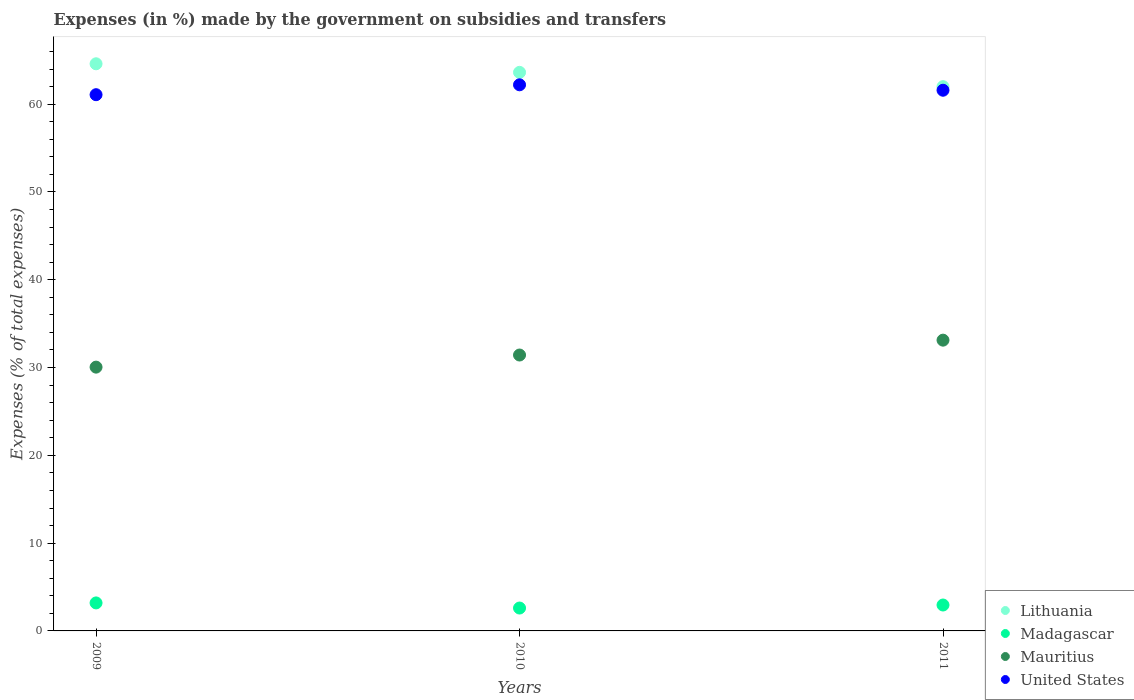How many different coloured dotlines are there?
Give a very brief answer. 4. Is the number of dotlines equal to the number of legend labels?
Give a very brief answer. Yes. What is the percentage of expenses made by the government on subsidies and transfers in United States in 2009?
Provide a short and direct response. 61.07. Across all years, what is the maximum percentage of expenses made by the government on subsidies and transfers in Mauritius?
Ensure brevity in your answer.  33.12. Across all years, what is the minimum percentage of expenses made by the government on subsidies and transfers in Madagascar?
Provide a succinct answer. 2.61. What is the total percentage of expenses made by the government on subsidies and transfers in Madagascar in the graph?
Ensure brevity in your answer.  8.75. What is the difference between the percentage of expenses made by the government on subsidies and transfers in Lithuania in 2009 and that in 2011?
Provide a short and direct response. 2.61. What is the difference between the percentage of expenses made by the government on subsidies and transfers in United States in 2011 and the percentage of expenses made by the government on subsidies and transfers in Madagascar in 2010?
Your response must be concise. 58.98. What is the average percentage of expenses made by the government on subsidies and transfers in United States per year?
Offer a very short reply. 61.62. In the year 2011, what is the difference between the percentage of expenses made by the government on subsidies and transfers in Mauritius and percentage of expenses made by the government on subsidies and transfers in United States?
Your response must be concise. -28.46. What is the ratio of the percentage of expenses made by the government on subsidies and transfers in United States in 2009 to that in 2011?
Your answer should be very brief. 0.99. What is the difference between the highest and the second highest percentage of expenses made by the government on subsidies and transfers in Mauritius?
Your answer should be compact. 1.69. What is the difference between the highest and the lowest percentage of expenses made by the government on subsidies and transfers in United States?
Your answer should be very brief. 1.13. Is it the case that in every year, the sum of the percentage of expenses made by the government on subsidies and transfers in Madagascar and percentage of expenses made by the government on subsidies and transfers in Lithuania  is greater than the sum of percentage of expenses made by the government on subsidies and transfers in United States and percentage of expenses made by the government on subsidies and transfers in Mauritius?
Provide a short and direct response. No. Is it the case that in every year, the sum of the percentage of expenses made by the government on subsidies and transfers in Lithuania and percentage of expenses made by the government on subsidies and transfers in United States  is greater than the percentage of expenses made by the government on subsidies and transfers in Mauritius?
Make the answer very short. Yes. Does the percentage of expenses made by the government on subsidies and transfers in United States monotonically increase over the years?
Your response must be concise. No. Is the percentage of expenses made by the government on subsidies and transfers in Mauritius strictly greater than the percentage of expenses made by the government on subsidies and transfers in Madagascar over the years?
Give a very brief answer. Yes. How many dotlines are there?
Ensure brevity in your answer.  4. How many legend labels are there?
Your response must be concise. 4. What is the title of the graph?
Ensure brevity in your answer.  Expenses (in %) made by the government on subsidies and transfers. Does "Tajikistan" appear as one of the legend labels in the graph?
Offer a very short reply. No. What is the label or title of the Y-axis?
Your answer should be very brief. Expenses (% of total expenses). What is the Expenses (% of total expenses) of Lithuania in 2009?
Your response must be concise. 64.59. What is the Expenses (% of total expenses) of Madagascar in 2009?
Provide a succinct answer. 3.19. What is the Expenses (% of total expenses) of Mauritius in 2009?
Give a very brief answer. 30.04. What is the Expenses (% of total expenses) in United States in 2009?
Ensure brevity in your answer.  61.07. What is the Expenses (% of total expenses) of Lithuania in 2010?
Your answer should be very brief. 63.62. What is the Expenses (% of total expenses) in Madagascar in 2010?
Ensure brevity in your answer.  2.61. What is the Expenses (% of total expenses) in Mauritius in 2010?
Provide a short and direct response. 31.42. What is the Expenses (% of total expenses) in United States in 2010?
Keep it short and to the point. 62.2. What is the Expenses (% of total expenses) of Lithuania in 2011?
Offer a terse response. 61.99. What is the Expenses (% of total expenses) in Madagascar in 2011?
Your answer should be compact. 2.95. What is the Expenses (% of total expenses) in Mauritius in 2011?
Provide a succinct answer. 33.12. What is the Expenses (% of total expenses) in United States in 2011?
Your answer should be compact. 61.58. Across all years, what is the maximum Expenses (% of total expenses) in Lithuania?
Make the answer very short. 64.59. Across all years, what is the maximum Expenses (% of total expenses) in Madagascar?
Your answer should be compact. 3.19. Across all years, what is the maximum Expenses (% of total expenses) in Mauritius?
Offer a terse response. 33.12. Across all years, what is the maximum Expenses (% of total expenses) in United States?
Keep it short and to the point. 62.2. Across all years, what is the minimum Expenses (% of total expenses) in Lithuania?
Ensure brevity in your answer.  61.99. Across all years, what is the minimum Expenses (% of total expenses) of Madagascar?
Your response must be concise. 2.61. Across all years, what is the minimum Expenses (% of total expenses) in Mauritius?
Offer a very short reply. 30.04. Across all years, what is the minimum Expenses (% of total expenses) of United States?
Your response must be concise. 61.07. What is the total Expenses (% of total expenses) of Lithuania in the graph?
Keep it short and to the point. 190.2. What is the total Expenses (% of total expenses) of Madagascar in the graph?
Keep it short and to the point. 8.75. What is the total Expenses (% of total expenses) in Mauritius in the graph?
Ensure brevity in your answer.  94.58. What is the total Expenses (% of total expenses) of United States in the graph?
Provide a short and direct response. 184.86. What is the difference between the Expenses (% of total expenses) in Lithuania in 2009 and that in 2010?
Ensure brevity in your answer.  0.98. What is the difference between the Expenses (% of total expenses) of Madagascar in 2009 and that in 2010?
Your answer should be very brief. 0.58. What is the difference between the Expenses (% of total expenses) of Mauritius in 2009 and that in 2010?
Ensure brevity in your answer.  -1.38. What is the difference between the Expenses (% of total expenses) in United States in 2009 and that in 2010?
Your answer should be very brief. -1.13. What is the difference between the Expenses (% of total expenses) of Lithuania in 2009 and that in 2011?
Your response must be concise. 2.61. What is the difference between the Expenses (% of total expenses) of Madagascar in 2009 and that in 2011?
Your answer should be very brief. 0.24. What is the difference between the Expenses (% of total expenses) of Mauritius in 2009 and that in 2011?
Your response must be concise. -3.07. What is the difference between the Expenses (% of total expenses) of United States in 2009 and that in 2011?
Provide a short and direct response. -0.51. What is the difference between the Expenses (% of total expenses) of Lithuania in 2010 and that in 2011?
Your answer should be very brief. 1.63. What is the difference between the Expenses (% of total expenses) in Madagascar in 2010 and that in 2011?
Offer a terse response. -0.34. What is the difference between the Expenses (% of total expenses) in Mauritius in 2010 and that in 2011?
Make the answer very short. -1.69. What is the difference between the Expenses (% of total expenses) in United States in 2010 and that in 2011?
Your answer should be compact. 0.62. What is the difference between the Expenses (% of total expenses) of Lithuania in 2009 and the Expenses (% of total expenses) of Madagascar in 2010?
Your answer should be very brief. 61.99. What is the difference between the Expenses (% of total expenses) in Lithuania in 2009 and the Expenses (% of total expenses) in Mauritius in 2010?
Provide a short and direct response. 33.17. What is the difference between the Expenses (% of total expenses) of Lithuania in 2009 and the Expenses (% of total expenses) of United States in 2010?
Your answer should be very brief. 2.39. What is the difference between the Expenses (% of total expenses) in Madagascar in 2009 and the Expenses (% of total expenses) in Mauritius in 2010?
Offer a terse response. -28.23. What is the difference between the Expenses (% of total expenses) of Madagascar in 2009 and the Expenses (% of total expenses) of United States in 2010?
Make the answer very short. -59.01. What is the difference between the Expenses (% of total expenses) in Mauritius in 2009 and the Expenses (% of total expenses) in United States in 2010?
Make the answer very short. -32.16. What is the difference between the Expenses (% of total expenses) of Lithuania in 2009 and the Expenses (% of total expenses) of Madagascar in 2011?
Your response must be concise. 61.64. What is the difference between the Expenses (% of total expenses) of Lithuania in 2009 and the Expenses (% of total expenses) of Mauritius in 2011?
Give a very brief answer. 31.48. What is the difference between the Expenses (% of total expenses) in Lithuania in 2009 and the Expenses (% of total expenses) in United States in 2011?
Offer a very short reply. 3.01. What is the difference between the Expenses (% of total expenses) in Madagascar in 2009 and the Expenses (% of total expenses) in Mauritius in 2011?
Your response must be concise. -29.93. What is the difference between the Expenses (% of total expenses) of Madagascar in 2009 and the Expenses (% of total expenses) of United States in 2011?
Keep it short and to the point. -58.39. What is the difference between the Expenses (% of total expenses) in Mauritius in 2009 and the Expenses (% of total expenses) in United States in 2011?
Your response must be concise. -31.54. What is the difference between the Expenses (% of total expenses) of Lithuania in 2010 and the Expenses (% of total expenses) of Madagascar in 2011?
Your response must be concise. 60.67. What is the difference between the Expenses (% of total expenses) of Lithuania in 2010 and the Expenses (% of total expenses) of Mauritius in 2011?
Make the answer very short. 30.5. What is the difference between the Expenses (% of total expenses) in Lithuania in 2010 and the Expenses (% of total expenses) in United States in 2011?
Offer a terse response. 2.04. What is the difference between the Expenses (% of total expenses) in Madagascar in 2010 and the Expenses (% of total expenses) in Mauritius in 2011?
Offer a terse response. -30.51. What is the difference between the Expenses (% of total expenses) of Madagascar in 2010 and the Expenses (% of total expenses) of United States in 2011?
Ensure brevity in your answer.  -58.98. What is the difference between the Expenses (% of total expenses) of Mauritius in 2010 and the Expenses (% of total expenses) of United States in 2011?
Offer a very short reply. -30.16. What is the average Expenses (% of total expenses) in Lithuania per year?
Make the answer very short. 63.4. What is the average Expenses (% of total expenses) in Madagascar per year?
Provide a succinct answer. 2.92. What is the average Expenses (% of total expenses) of Mauritius per year?
Offer a terse response. 31.53. What is the average Expenses (% of total expenses) of United States per year?
Offer a very short reply. 61.62. In the year 2009, what is the difference between the Expenses (% of total expenses) of Lithuania and Expenses (% of total expenses) of Madagascar?
Your answer should be compact. 61.4. In the year 2009, what is the difference between the Expenses (% of total expenses) in Lithuania and Expenses (% of total expenses) in Mauritius?
Keep it short and to the point. 34.55. In the year 2009, what is the difference between the Expenses (% of total expenses) of Lithuania and Expenses (% of total expenses) of United States?
Provide a short and direct response. 3.52. In the year 2009, what is the difference between the Expenses (% of total expenses) of Madagascar and Expenses (% of total expenses) of Mauritius?
Your response must be concise. -26.86. In the year 2009, what is the difference between the Expenses (% of total expenses) of Madagascar and Expenses (% of total expenses) of United States?
Give a very brief answer. -57.89. In the year 2009, what is the difference between the Expenses (% of total expenses) of Mauritius and Expenses (% of total expenses) of United States?
Your response must be concise. -31.03. In the year 2010, what is the difference between the Expenses (% of total expenses) of Lithuania and Expenses (% of total expenses) of Madagascar?
Provide a succinct answer. 61.01. In the year 2010, what is the difference between the Expenses (% of total expenses) of Lithuania and Expenses (% of total expenses) of Mauritius?
Your answer should be very brief. 32.19. In the year 2010, what is the difference between the Expenses (% of total expenses) in Lithuania and Expenses (% of total expenses) in United States?
Provide a short and direct response. 1.42. In the year 2010, what is the difference between the Expenses (% of total expenses) in Madagascar and Expenses (% of total expenses) in Mauritius?
Offer a very short reply. -28.82. In the year 2010, what is the difference between the Expenses (% of total expenses) of Madagascar and Expenses (% of total expenses) of United States?
Ensure brevity in your answer.  -59.59. In the year 2010, what is the difference between the Expenses (% of total expenses) in Mauritius and Expenses (% of total expenses) in United States?
Your answer should be very brief. -30.78. In the year 2011, what is the difference between the Expenses (% of total expenses) of Lithuania and Expenses (% of total expenses) of Madagascar?
Your answer should be very brief. 59.04. In the year 2011, what is the difference between the Expenses (% of total expenses) of Lithuania and Expenses (% of total expenses) of Mauritius?
Keep it short and to the point. 28.87. In the year 2011, what is the difference between the Expenses (% of total expenses) of Lithuania and Expenses (% of total expenses) of United States?
Your answer should be compact. 0.41. In the year 2011, what is the difference between the Expenses (% of total expenses) in Madagascar and Expenses (% of total expenses) in Mauritius?
Make the answer very short. -30.17. In the year 2011, what is the difference between the Expenses (% of total expenses) in Madagascar and Expenses (% of total expenses) in United States?
Ensure brevity in your answer.  -58.63. In the year 2011, what is the difference between the Expenses (% of total expenses) in Mauritius and Expenses (% of total expenses) in United States?
Provide a short and direct response. -28.46. What is the ratio of the Expenses (% of total expenses) of Lithuania in 2009 to that in 2010?
Give a very brief answer. 1.02. What is the ratio of the Expenses (% of total expenses) in Madagascar in 2009 to that in 2010?
Your response must be concise. 1.22. What is the ratio of the Expenses (% of total expenses) of Mauritius in 2009 to that in 2010?
Provide a succinct answer. 0.96. What is the ratio of the Expenses (% of total expenses) of United States in 2009 to that in 2010?
Your answer should be compact. 0.98. What is the ratio of the Expenses (% of total expenses) of Lithuania in 2009 to that in 2011?
Ensure brevity in your answer.  1.04. What is the ratio of the Expenses (% of total expenses) of Madagascar in 2009 to that in 2011?
Provide a short and direct response. 1.08. What is the ratio of the Expenses (% of total expenses) of Mauritius in 2009 to that in 2011?
Your answer should be compact. 0.91. What is the ratio of the Expenses (% of total expenses) of United States in 2009 to that in 2011?
Your answer should be compact. 0.99. What is the ratio of the Expenses (% of total expenses) of Lithuania in 2010 to that in 2011?
Offer a terse response. 1.03. What is the ratio of the Expenses (% of total expenses) in Madagascar in 2010 to that in 2011?
Your answer should be compact. 0.88. What is the ratio of the Expenses (% of total expenses) of Mauritius in 2010 to that in 2011?
Make the answer very short. 0.95. What is the difference between the highest and the second highest Expenses (% of total expenses) of Lithuania?
Offer a terse response. 0.98. What is the difference between the highest and the second highest Expenses (% of total expenses) in Madagascar?
Offer a terse response. 0.24. What is the difference between the highest and the second highest Expenses (% of total expenses) in Mauritius?
Offer a very short reply. 1.69. What is the difference between the highest and the second highest Expenses (% of total expenses) of United States?
Ensure brevity in your answer.  0.62. What is the difference between the highest and the lowest Expenses (% of total expenses) of Lithuania?
Offer a very short reply. 2.61. What is the difference between the highest and the lowest Expenses (% of total expenses) of Madagascar?
Your response must be concise. 0.58. What is the difference between the highest and the lowest Expenses (% of total expenses) in Mauritius?
Provide a succinct answer. 3.07. What is the difference between the highest and the lowest Expenses (% of total expenses) of United States?
Your answer should be compact. 1.13. 